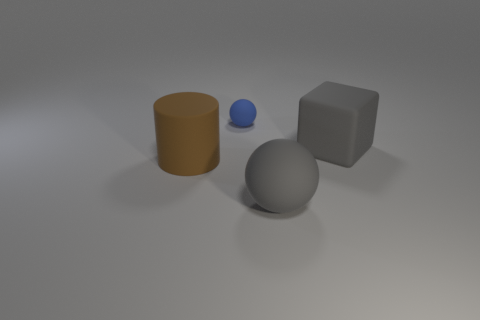Add 4 small matte objects. How many objects exist? 8 Subtract all cylinders. How many objects are left? 3 Subtract all gray rubber things. Subtract all spheres. How many objects are left? 0 Add 2 tiny blue rubber spheres. How many tiny blue rubber spheres are left? 3 Add 2 tiny things. How many tiny things exist? 3 Subtract 1 gray blocks. How many objects are left? 3 